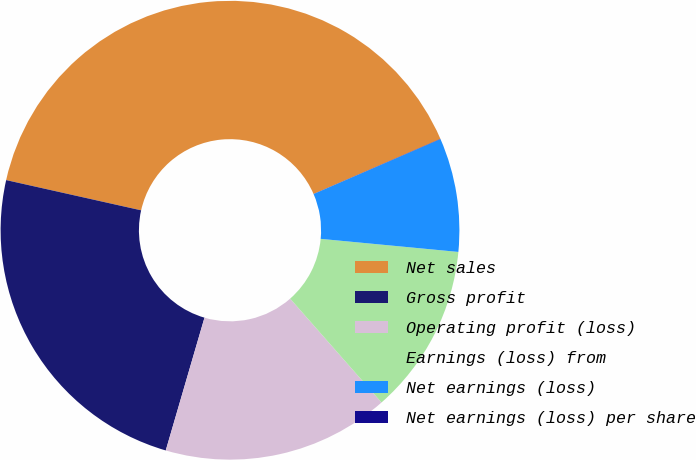Convert chart to OTSL. <chart><loc_0><loc_0><loc_500><loc_500><pie_chart><fcel>Net sales<fcel>Gross profit<fcel>Operating profit (loss)<fcel>Earnings (loss) from<fcel>Net earnings (loss)<fcel>Net earnings (loss) per share<nl><fcel>39.97%<fcel>23.99%<fcel>16.0%<fcel>12.01%<fcel>8.01%<fcel>0.02%<nl></chart> 